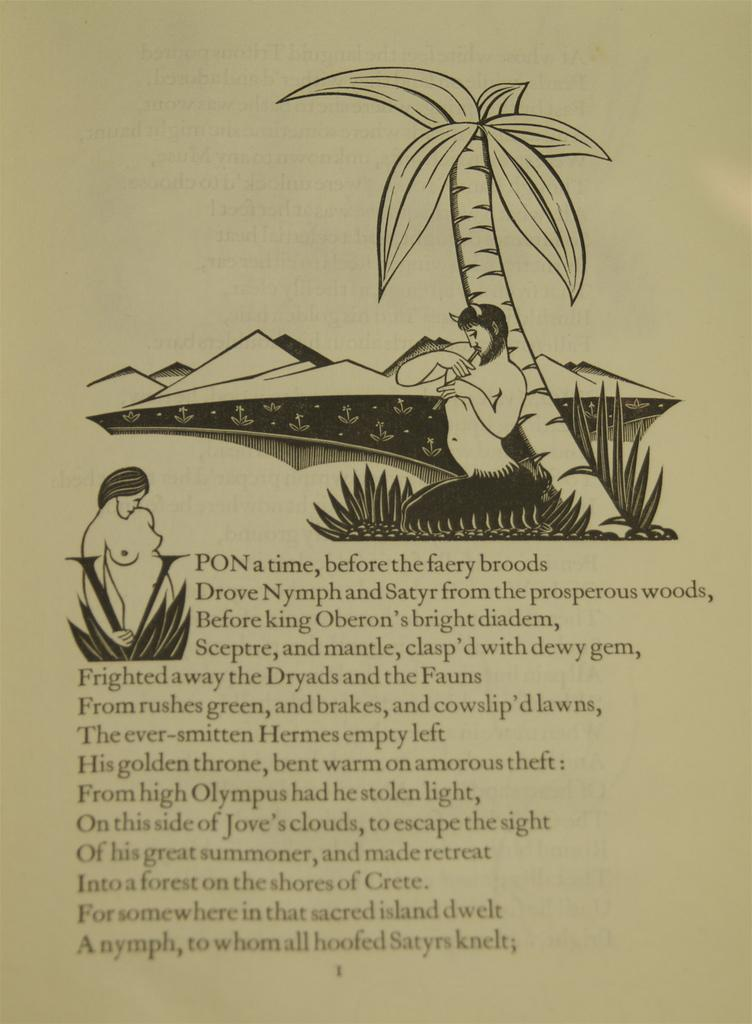What is the main subject of the photo in the image? There is a photo of paper in the image. Who or what can be seen in the photo? There are two women in the photo. Is there any text present on the photo? Yes, there is text on the photo. Can you tell me how many boats are visible in the photo? There are no boats present in the photo; it features a photo of paper with two women and text. What type of tax is being discussed in the photo? There is no mention of tax in the photo; it only contains an image of two women and text. 